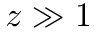<formula> <loc_0><loc_0><loc_500><loc_500>z \gg 1</formula> 